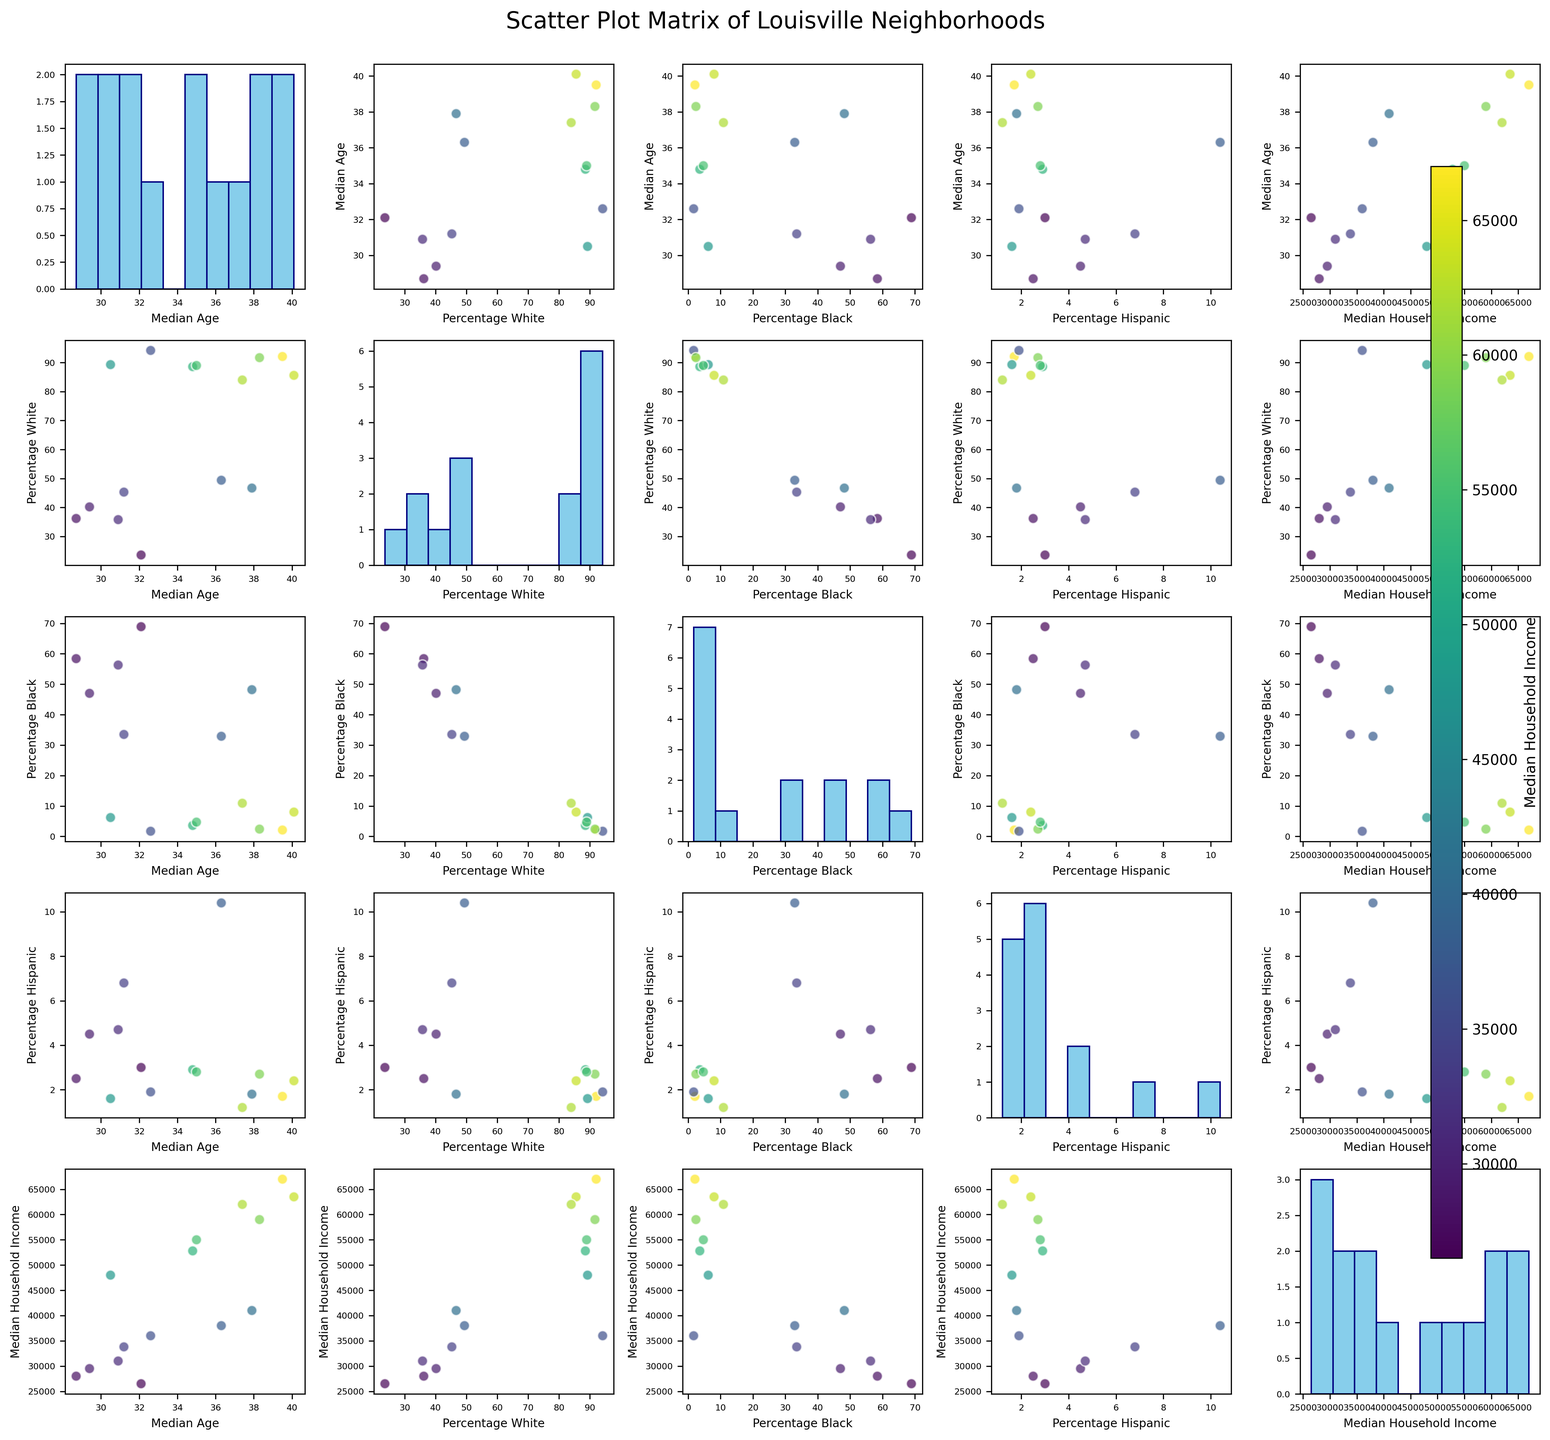What is the title of the figure? The title of the figure is usually placed at the top center of the scatter plot matrix. It provides a brief description of the visual representation. By looking at the figure, it reads 'Scatter Plot Matrix of Louisville Neighborhoods'.
Answer: Scatter Plot Matrix of Louisville Neighborhoods How many data points are represented in each scatter plot? Each scatter plot in the matrix represents data points corresponding to the 15 neighborhoods. This can be counted by looking at the dots in any scatter plot panel.
Answer: 15 Which neighborhood has the highest Median Household Income based on the figure? To find which neighborhood has the highest Median Household Income, one can look at the color bar and identify the dot that correlates to the highest income level color, then check the label. The darkest colored dot indicates the highest income, which is St. Matthews with $67,000.
Answer: St. Matthews Is there a strong correlation between Median Age and Median Household Income? To determine the correlation between Median Age and Median Household Income, look at the scatter plot where Median Age is on one axis and Median Household Income is on the other. If the dots form a pattern or trend line, this indicates a correlation. However, based on the scatter plot matrix, the dots appear quite scattered, indicating a weak or no strong correlation.
Answer: No Which two variables seem to have the strongest positive correlation? By comparing all scatter plot panels, the one with the dots most closely aligned forms a line indicating the strongest correlation. The scatter plot between 'Percentage Black' and 'Percentage White' shows a clear negative correlation (as one increases, the other decreases), but for positive correlation, 'Median Age' and 'Percentage White' seem to align positively.
Answer: Median Age and Percentage White What do the colors in the scatter plots represent? The colors in the scatter plots represent the Median Household Income. This is illustrated by the color bar on the right side of the figure, where varying shades from light to dark correspond to different income levels.
Answer: Median Household Income Which neighborhood has the lowest Median Household Income and what is the corresponding color on the scatter plots? To find the neighborhood with the lowest Median Household Income, look at the color bar and identify the lightest color, then match it to the corresponding data point. The lightest color represents the lowest income, which is $26,500 for the West End.
Answer: West End, light color Is there a notable distribution trend for Median Age across neighborhoods? Look at the histogram on the diagonal where Median Age is plotted. This shows the frequency distribution of ages across neighborhoods. The distribution appears to be relatively uniform, with no pronounced peaks or troughs.
Answer: Uniform distribution Among the neighborhoods with a high Percentage Black, how does the Median Household Income generally trend? By looking at scatter plots involving Percentage Black and noting the color of the dots (indicating income), it can be observed that neighborhoods with a high Percentage Black generally trend towards lower Median Household Incomes, as the dots are lighter in color.
Answer: Lower income Which variable seems to show the most variation in its distribution among the neighborhoods? By examining the histograms on the diagonal, we can see which variable has the widest spread. The histogram for Percentage Black shows a wide distribution range, indicating significant variation among the neighborhoods.
Answer: Percentage Black 